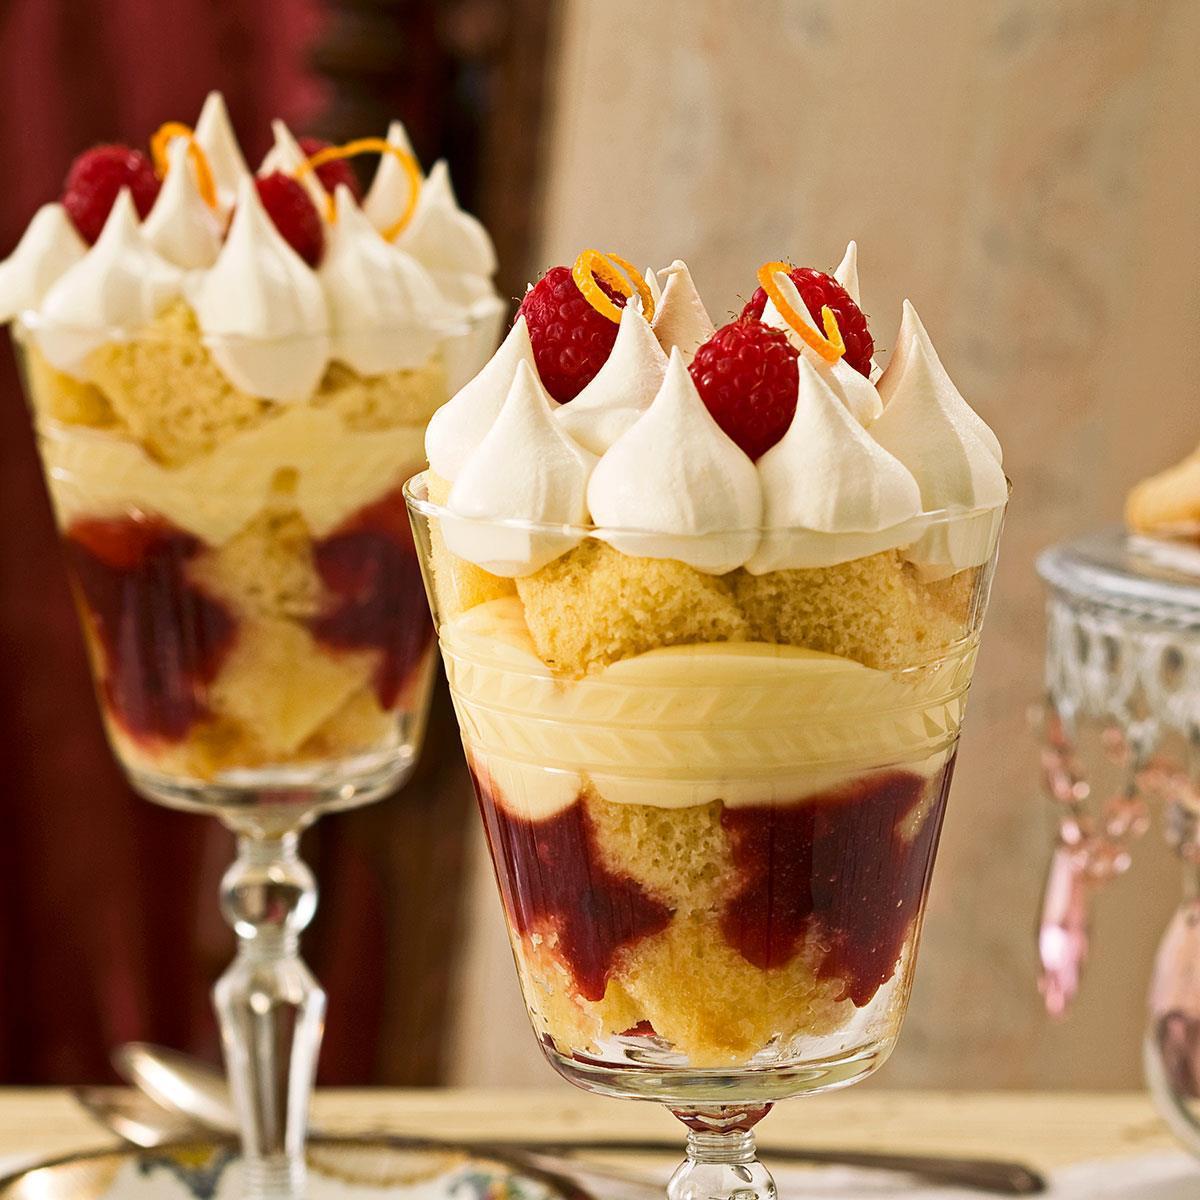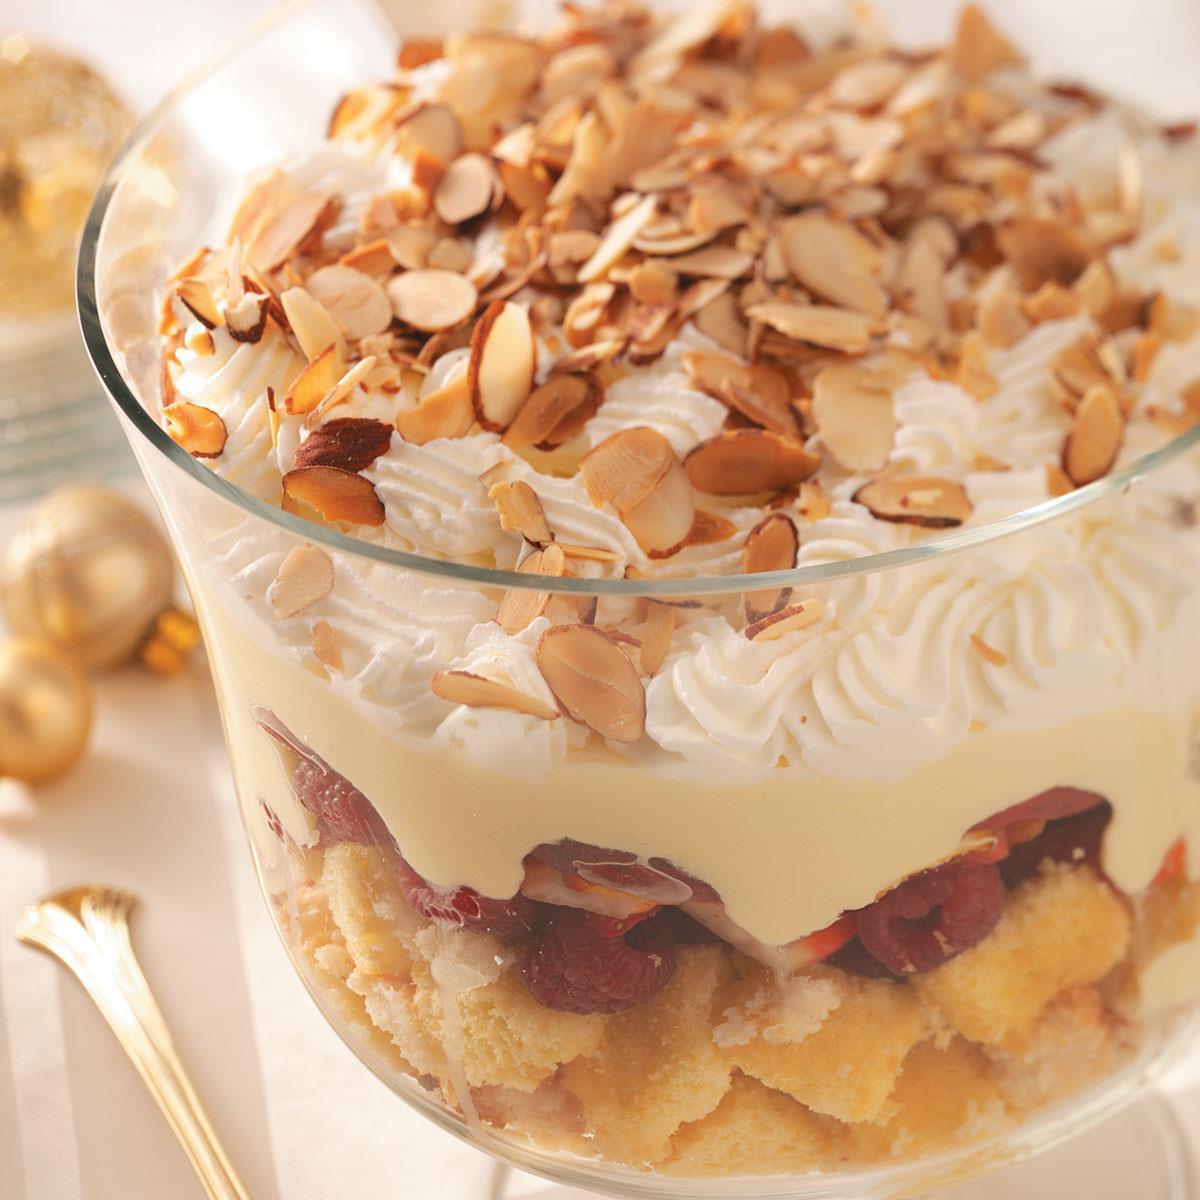The first image is the image on the left, the second image is the image on the right. Evaluate the accuracy of this statement regarding the images: "One image shows a dessert topped with sliced, non-heaped strawberries, and the other shows a dessert topped with a different kind of small bright red fruit.". Is it true? Answer yes or no. No. The first image is the image on the left, the second image is the image on the right. Analyze the images presented: Is the assertion "A single dessert in the image on the left has a glass pedestal." valid? Answer yes or no. No. 